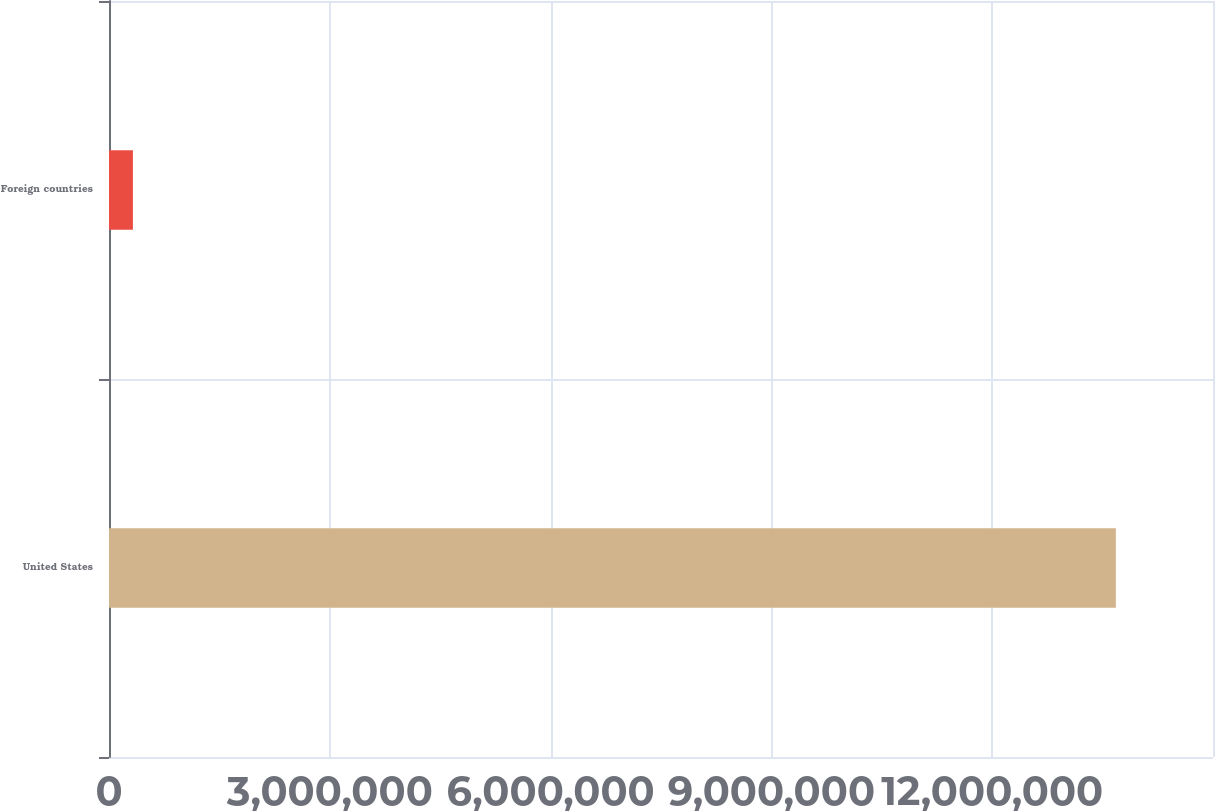Convert chart to OTSL. <chart><loc_0><loc_0><loc_500><loc_500><bar_chart><fcel>United States<fcel>Foreign countries<nl><fcel>1.36802e+07<fcel>325041<nl></chart> 